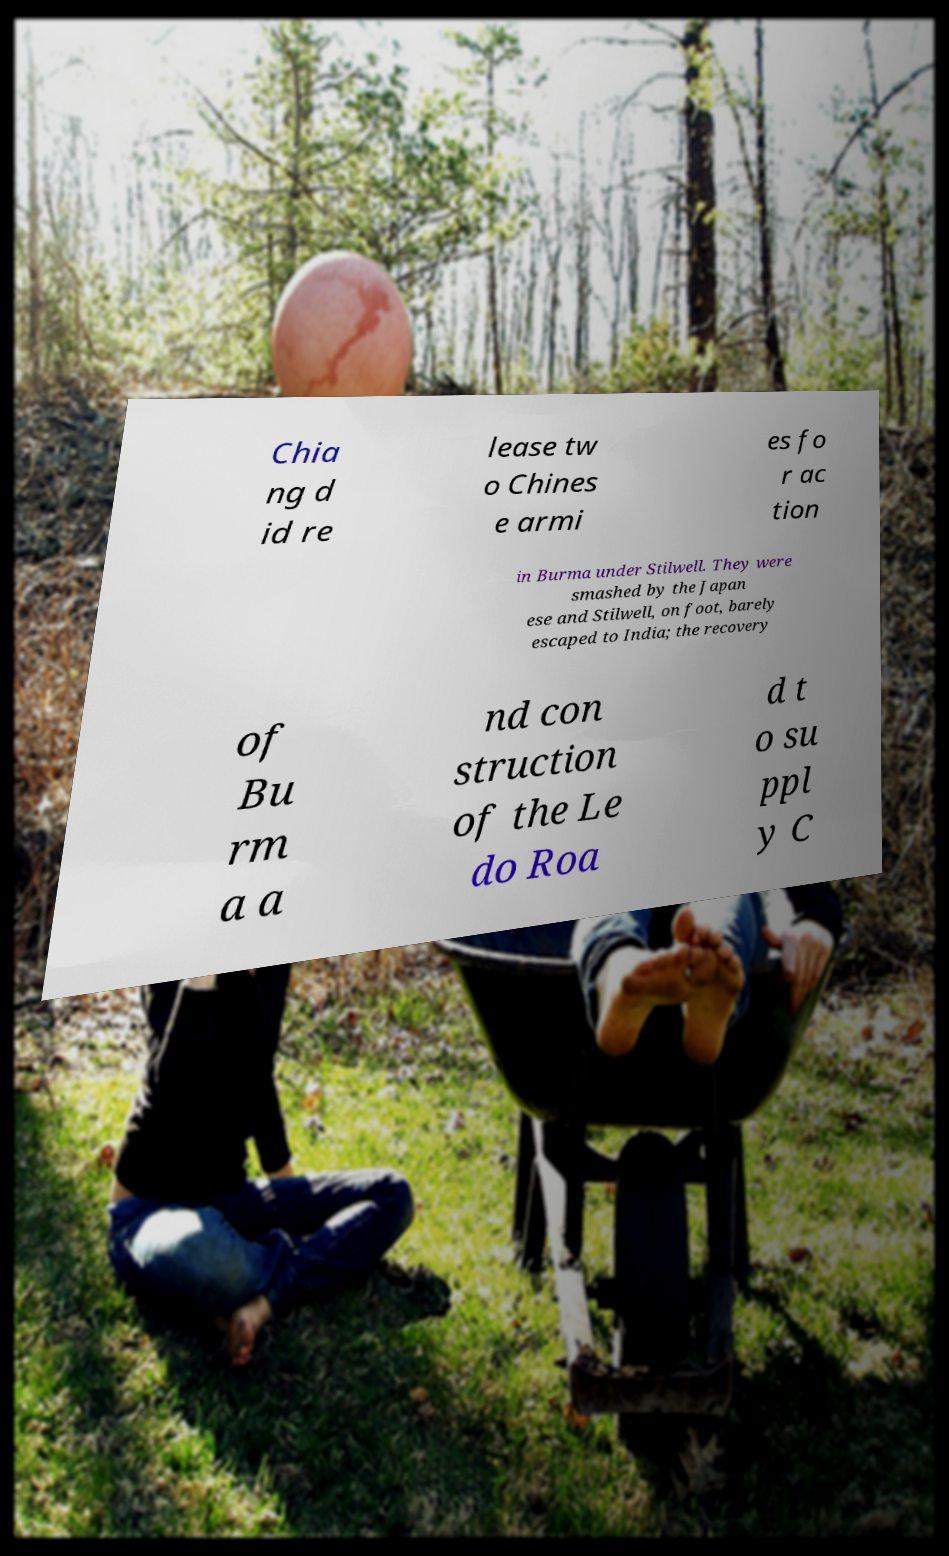I need the written content from this picture converted into text. Can you do that? Chia ng d id re lease tw o Chines e armi es fo r ac tion in Burma under Stilwell. They were smashed by the Japan ese and Stilwell, on foot, barely escaped to India; the recovery of Bu rm a a nd con struction of the Le do Roa d t o su ppl y C 